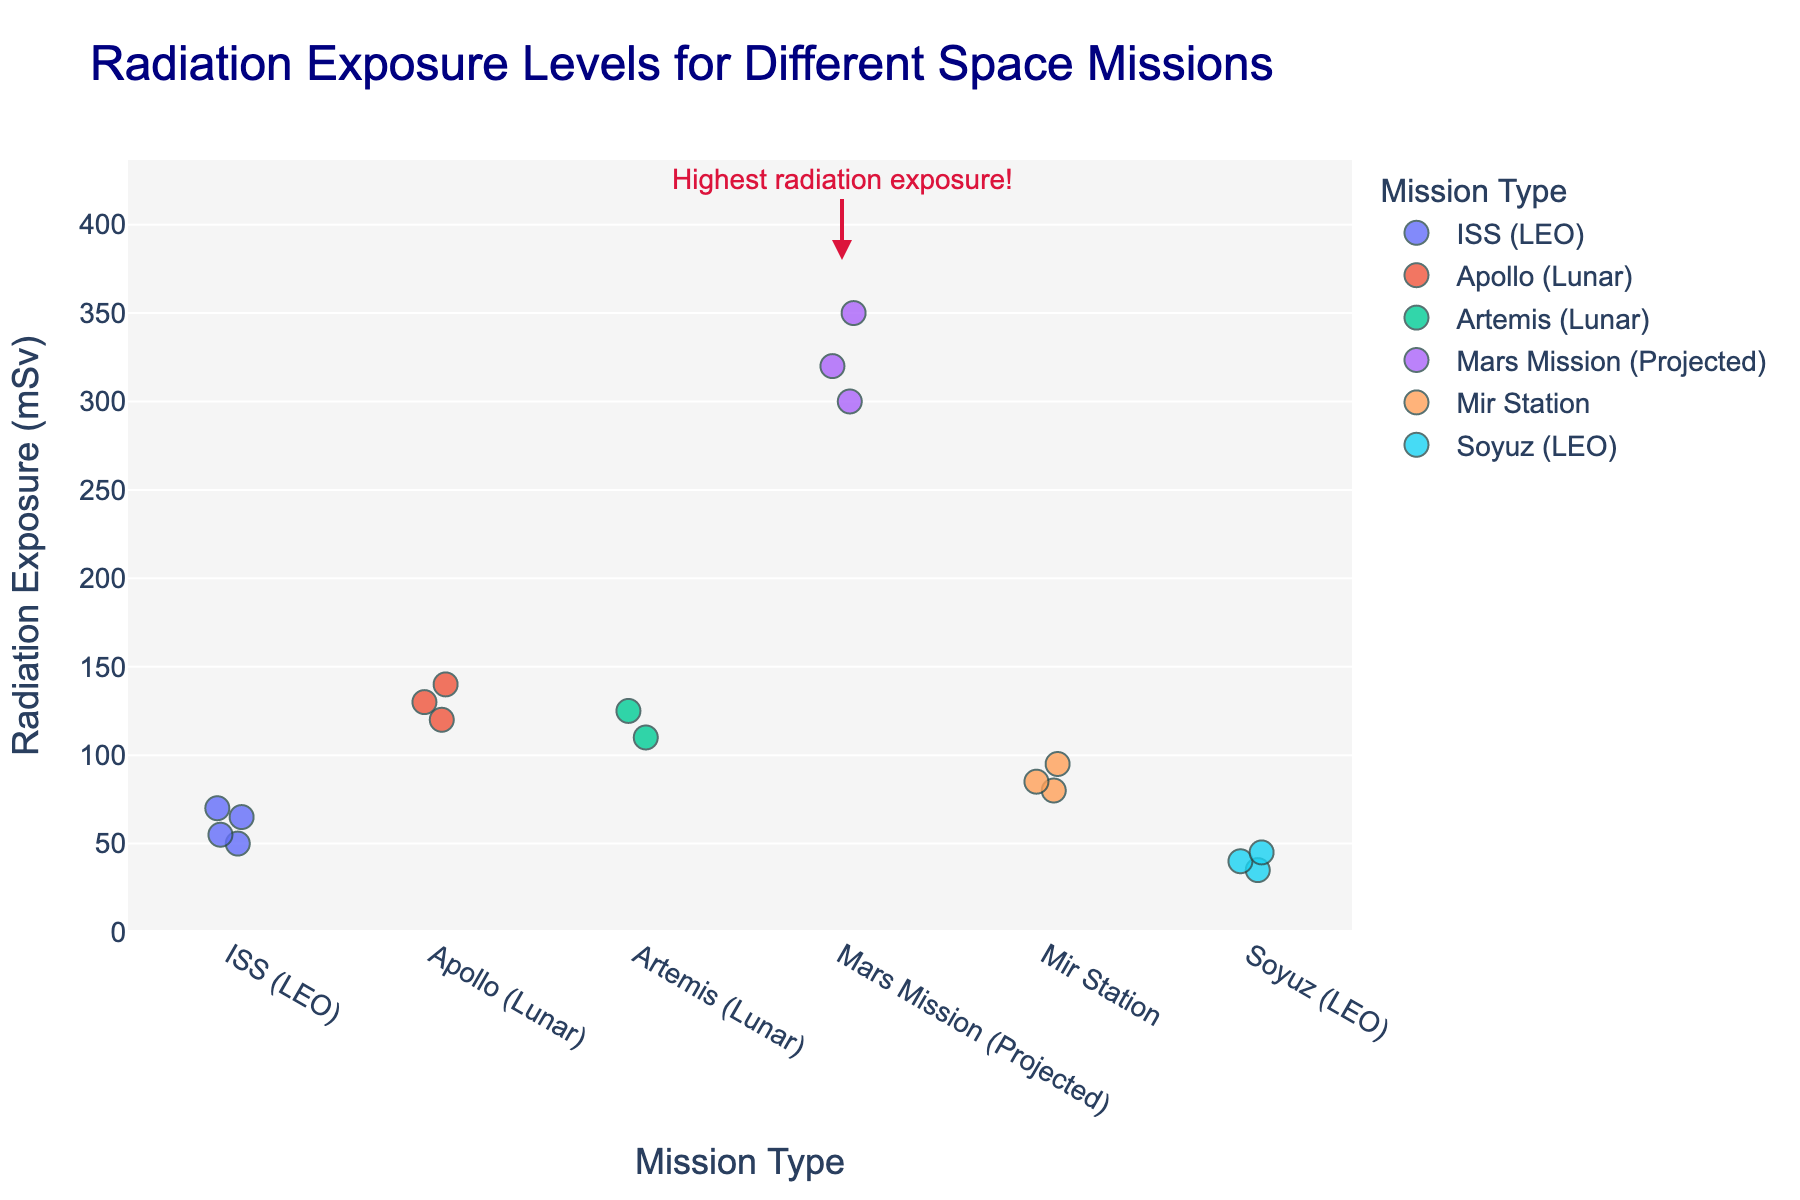How many mission types are compared in the plot? Count the distinct mission types listed on the x-axis.
Answer: 6 What is the highest radiation exposure recorded for the Soyuz mission? Look for the highest data point in the 'Soyuz (LEO)' category along the y-axis.
Answer: 45 mSv Which mission type experienced the highest average radiation exposure? Visually estimate the central tendency of the data points for each mission type; the 'Mars Mission (Projected)' category has the highest clustered values.
Answer: Mars Mission (Projected) How does the average radiation exposure for the ISS (LEO) mission compare to that of the Mir Station? Estimate the average height of the data points in the 'ISS (LEO)' group and compare it to 'Mir Station'. The average for 'ISS (LEO)' is lower than 'Mir Station'.
Answer: ISS (LEO) < Mir Station Which mission type has the lowest radiation exposure recorded, and what is the value? Locate the lowest data point overall and note its corresponding mission type and value.
Answer: Soyuz (LEO), 35 mSv How spread out are the radiation exposure levels for the Apollo and Artemis missions? Observe and compare the vertical spread of the data points in both the 'Apollo (Lunar)' and 'Artemis (Lunar)' categories.
Answer: Apollo (Lunar) has a wider spread than Artemis (Lunar) What does the annotation in the 'Mars Mission (Projected)' category signify? Read the text annotation and understand its context; it highlights exposure levels and mentions "Highest radiation exposure!".
Answer: Highest radiation exposure! Compare the highest radiation exposure value between ISS (LEO) and Apollo (Lunar) missions Identify and compare the highest data points in each category.
Answer: Apollo (Lunar) > ISS (LEO) What is the range of radiation exposure values recorded for the ISS (LEO) mission? Identify the minimum and maximum values within the 'ISS (LEO)' group and calculate the range (70 - 50).
Answer: 20 mSv How does the highest radiation exposure recorded for the Mir Station compare to that of the Mars Mission (Projected)? Compare the highest data points of 'Mir Station' (95 mSv) and 'Mars Mission (Projected)' (350 mSv).
Answer: Mars Mission (Projected) > Mir Station 